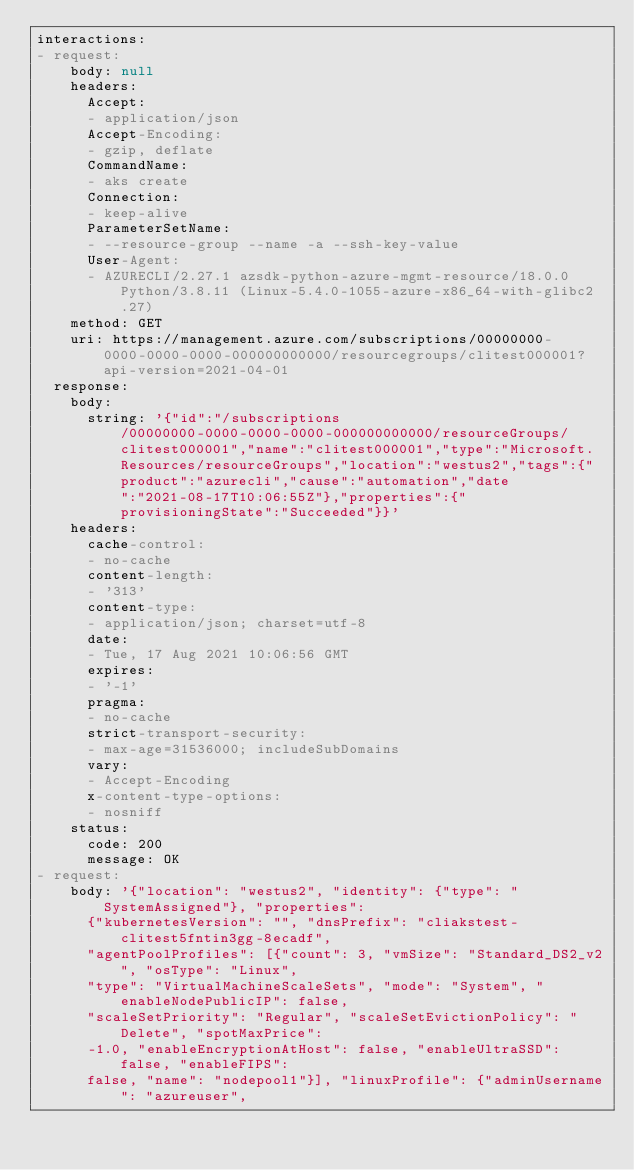Convert code to text. <code><loc_0><loc_0><loc_500><loc_500><_YAML_>interactions:
- request:
    body: null
    headers:
      Accept:
      - application/json
      Accept-Encoding:
      - gzip, deflate
      CommandName:
      - aks create
      Connection:
      - keep-alive
      ParameterSetName:
      - --resource-group --name -a --ssh-key-value
      User-Agent:
      - AZURECLI/2.27.1 azsdk-python-azure-mgmt-resource/18.0.0 Python/3.8.11 (Linux-5.4.0-1055-azure-x86_64-with-glibc2.27)
    method: GET
    uri: https://management.azure.com/subscriptions/00000000-0000-0000-0000-000000000000/resourcegroups/clitest000001?api-version=2021-04-01
  response:
    body:
      string: '{"id":"/subscriptions/00000000-0000-0000-0000-000000000000/resourceGroups/clitest000001","name":"clitest000001","type":"Microsoft.Resources/resourceGroups","location":"westus2","tags":{"product":"azurecli","cause":"automation","date":"2021-08-17T10:06:55Z"},"properties":{"provisioningState":"Succeeded"}}'
    headers:
      cache-control:
      - no-cache
      content-length:
      - '313'
      content-type:
      - application/json; charset=utf-8
      date:
      - Tue, 17 Aug 2021 10:06:56 GMT
      expires:
      - '-1'
      pragma:
      - no-cache
      strict-transport-security:
      - max-age=31536000; includeSubDomains
      vary:
      - Accept-Encoding
      x-content-type-options:
      - nosniff
    status:
      code: 200
      message: OK
- request:
    body: '{"location": "westus2", "identity": {"type": "SystemAssigned"}, "properties":
      {"kubernetesVersion": "", "dnsPrefix": "cliakstest-clitest5fntin3gg-8ecadf",
      "agentPoolProfiles": [{"count": 3, "vmSize": "Standard_DS2_v2", "osType": "Linux",
      "type": "VirtualMachineScaleSets", "mode": "System", "enableNodePublicIP": false,
      "scaleSetPriority": "Regular", "scaleSetEvictionPolicy": "Delete", "spotMaxPrice":
      -1.0, "enableEncryptionAtHost": false, "enableUltraSSD": false, "enableFIPS":
      false, "name": "nodepool1"}], "linuxProfile": {"adminUsername": "azureuser",</code> 